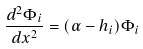Convert formula to latex. <formula><loc_0><loc_0><loc_500><loc_500>\frac { d ^ { 2 } \Phi _ { i } } { d x ^ { 2 } } = ( \alpha - h _ { i } ) \Phi _ { i }</formula> 